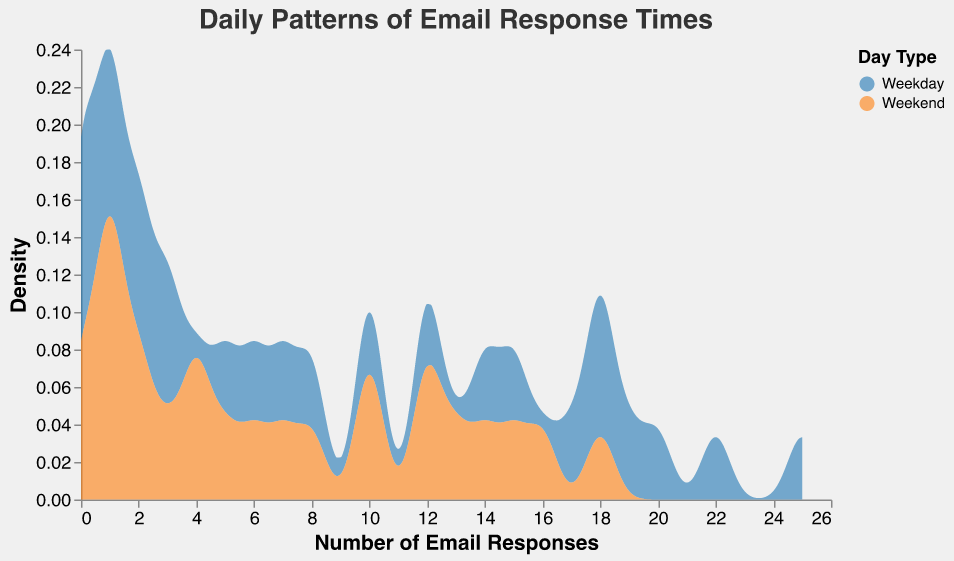What is the title of the plot? The title is usually displayed prominently at the top of the plot. In this case, it states the main subject of the visualization.
Answer: Daily Patterns of Email Response Times What are the two types of days represented in the plot? The legend or color encoding section indicates the different categories used in the plot. Here, there are two Day Types distinguished by color.
Answer: Weekday and Weekend Which Day Type has more Email Responses around noon? To determine this, observe the density values at the 12:00 position for both Weekday and Weekend categories. The category with the higher density shows more email responses around that time.
Answer: Weekday At what time does the peak Email Response occur on Weekdays? Look for the highest point or peak on the density curve for Weekdays. This will give the time of the peak email response.
Answer: 12:00 How do the email response densities compare between weekdays and weekends during the early morning hours (between 00:00 and 06:00)? Examine the density curves for Weekdays and Weekends during the interval of 00:00 to 06:00. Compare to see which has higher or lower density values.
Answer: Weekdays have higher densities before 04:00, and weekends show slightly higher densities closer to 06:00 Which Day Type experiences a more significant drop in Email Responses after 17:00? Look at the slope of the density curves after the 17:00 mark. The Day Type with a steeper decline indicates a more significant drop in email responses.
Answer: Weekday What is the spread of the Email Responses indicated by in the plot? The spread is shown by the width of the density plot along the x-axis. This tells how Email Responses are distributed across different times of the day.
Answer: Number of Email Responses axis Compare the Email Response densities at 09:00 between Weekday and Weekend. Which one is higher? Examine the density values at the specific time point of 09:00 for both Weekday and Weekend. The one with the higher density indicates more email responses at that time.
Answer: Weekday During which hours do Weekends experience the highest density of Email Responses? Identify the peak point of the density curve for Weekends and note the corresponding hours.
Answer: 12:00 - 14:00 Explain the trend of email responses throughout the day on Weekdays. Observe the density curve for Weekdays from the start to the end of the day. Describe the main peaks and troughs and the overall pattern of email responses.
Answer: Peaks at noon, gradual decrease after 13:00, lower responses in early morning and late evening 